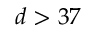<formula> <loc_0><loc_0><loc_500><loc_500>d > 3 7</formula> 